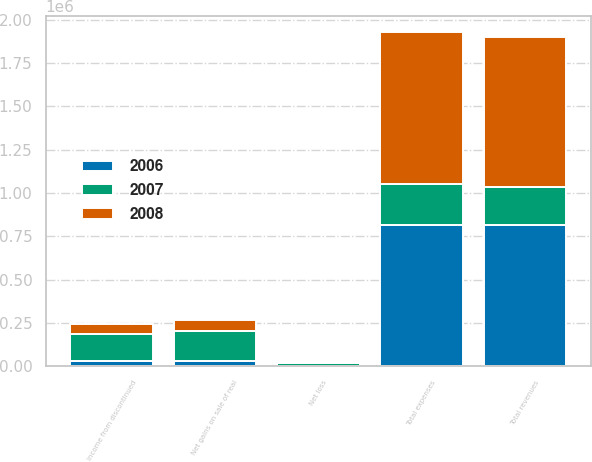Convert chart. <chart><loc_0><loc_0><loc_500><loc_500><stacked_bar_chart><ecel><fcel>Total revenues<fcel>Total expenses<fcel>Net loss<fcel>Net gains on sale of real<fcel>Income from discontinued<nl><fcel>2007<fcel>222361<fcel>238132<fcel>15771<fcel>170213<fcel>154442<nl><fcel>2008<fcel>865584<fcel>872176<fcel>6592<fcel>64981<fcel>58389<nl><fcel>2006<fcel>813665<fcel>815219<fcel>1554<fcel>33769<fcel>32215<nl></chart> 